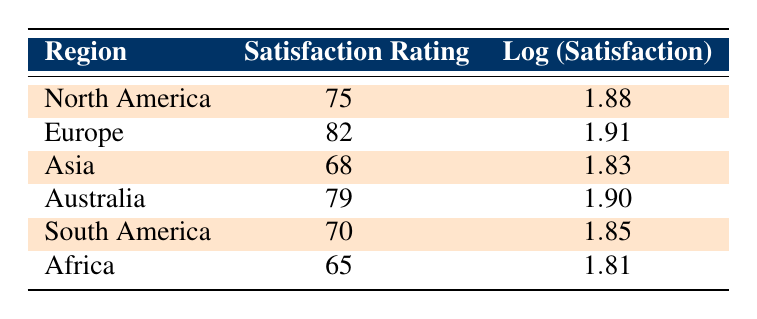What is the satisfaction rating for Europe? The table clearly shows that the satisfaction rating for Europe is listed directly next to the region. It states 82 for Europe.
Answer: 82 Which region has the lowest satisfaction rating? By scanning the satisfaction ratings in the table, we can see that Africa has the lowest rating at 65.
Answer: Africa What is the logarithmic value for the satisfaction rating in Asia? The table displays the logarithmic value for Asia’s satisfaction rating, which is directly listed as 1.83.
Answer: 1.83 What is the average satisfaction rating for all regions? To find the average, we first sum all satisfaction ratings: 75 + 82 + 68 + 79 + 70 + 65 = 439. Then, we divide this sum by the number of regions (6): 439 / 6 = 73.17.
Answer: 73.17 Is the satisfaction rating for South America higher than the satisfaction rating for Africa? From the table, South America's rating is 70, and Africa's rating is 65. Since 70 is greater than 65, the statement is true.
Answer: Yes What is the difference between the highest and lowest satisfaction ratings? The highest satisfaction rating is for Europe (82) and the lowest for Africa (65). Calculating the difference: 82 - 65 = 17.
Answer: 17 Which region has a satisfaction rating that is close to 80? Checking the table, we see that both Australia (79) and Europe (82) have ratings close to 80.
Answer: Australia and Europe Do any regions have a satisfaction rating below 70? By looking at the table, we can identify that Asia (68) and Africa (65) have ratings below 70. Therefore, the statement is true.
Answer: Yes What is the sum of logarithmic values for the satisfaction ratings of all regions? We add the logarithmic values: 1.88 + 1.91 + 1.83 + 1.90 + 1.85 + 1.81 = 11.18.
Answer: 11.18 